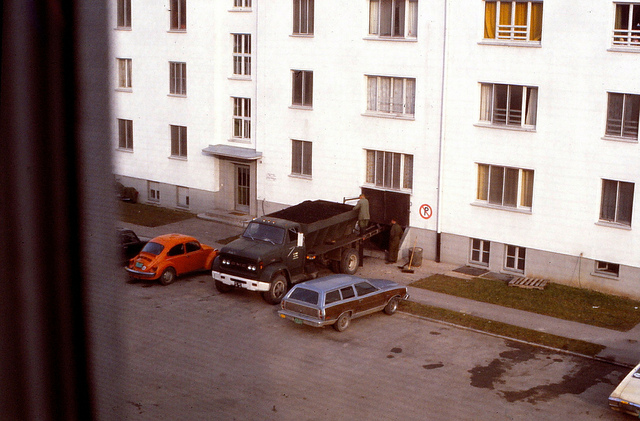Identify the text contained in this image. R 